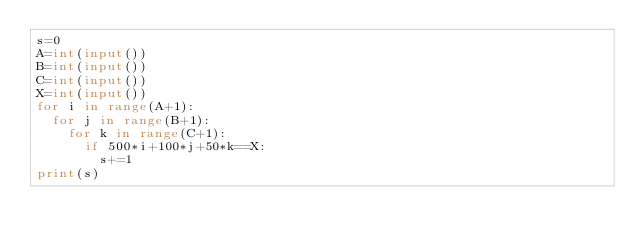Convert code to text. <code><loc_0><loc_0><loc_500><loc_500><_Python_>s=0
A=int(input())
B=int(input())
C=int(input())
X=int(input())
for i in range(A+1):
  for j in range(B+1):
    for k in range(C+1):
      if 500*i+100*j+50*k==X:
        s+=1
print(s)</code> 